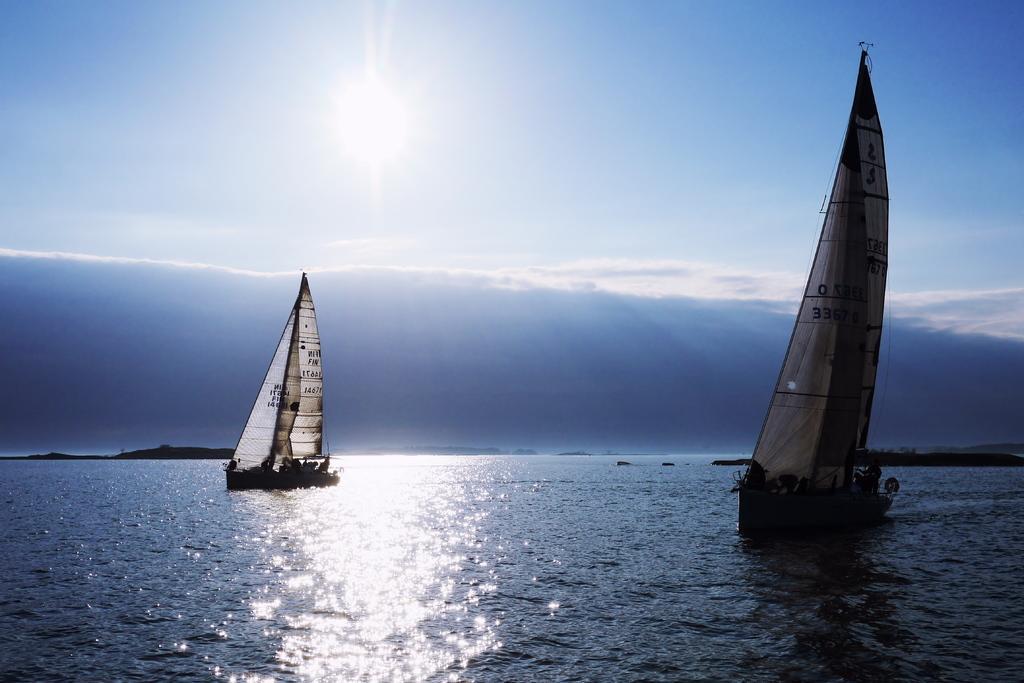Please provide a concise description of this image. In this image, I can see two sailboats on the water. This looks like a sea. This is the sky. In the background, I can see the kind of island. 